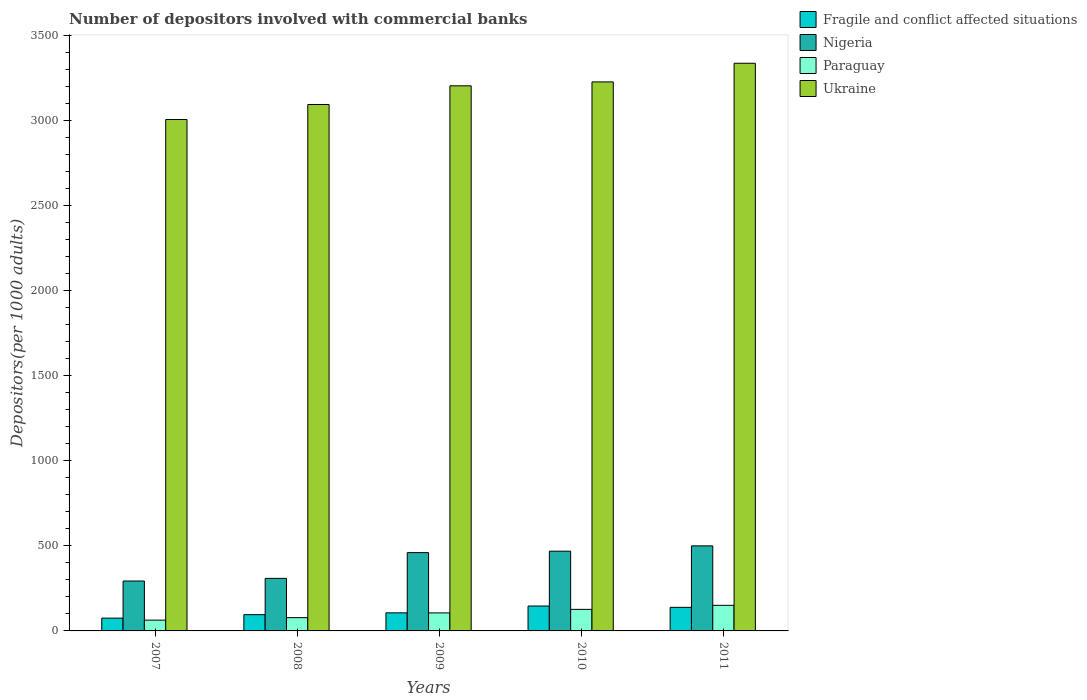Are the number of bars per tick equal to the number of legend labels?
Provide a short and direct response. Yes. Are the number of bars on each tick of the X-axis equal?
Your answer should be very brief. Yes. How many bars are there on the 2nd tick from the right?
Ensure brevity in your answer.  4. In how many cases, is the number of bars for a given year not equal to the number of legend labels?
Make the answer very short. 0. What is the number of depositors involved with commercial banks in Fragile and conflict affected situations in 2010?
Your answer should be very brief. 146.5. Across all years, what is the maximum number of depositors involved with commercial banks in Nigeria?
Your answer should be very brief. 500.36. Across all years, what is the minimum number of depositors involved with commercial banks in Fragile and conflict affected situations?
Provide a short and direct response. 75.3. In which year was the number of depositors involved with commercial banks in Paraguay minimum?
Your answer should be compact. 2007. What is the total number of depositors involved with commercial banks in Paraguay in the graph?
Your answer should be compact. 524.67. What is the difference between the number of depositors involved with commercial banks in Fragile and conflict affected situations in 2007 and that in 2008?
Keep it short and to the point. -20.35. What is the difference between the number of depositors involved with commercial banks in Nigeria in 2008 and the number of depositors involved with commercial banks in Fragile and conflict affected situations in 2011?
Your answer should be very brief. 170.43. What is the average number of depositors involved with commercial banks in Ukraine per year?
Offer a terse response. 3176.16. In the year 2010, what is the difference between the number of depositors involved with commercial banks in Ukraine and number of depositors involved with commercial banks in Paraguay?
Offer a terse response. 3102.9. In how many years, is the number of depositors involved with commercial banks in Fragile and conflict affected situations greater than 1100?
Offer a terse response. 0. What is the ratio of the number of depositors involved with commercial banks in Paraguay in 2007 to that in 2009?
Make the answer very short. 0.6. What is the difference between the highest and the second highest number of depositors involved with commercial banks in Nigeria?
Your answer should be compact. 31.38. What is the difference between the highest and the lowest number of depositors involved with commercial banks in Nigeria?
Ensure brevity in your answer.  206.77. Is the sum of the number of depositors involved with commercial banks in Fragile and conflict affected situations in 2007 and 2009 greater than the maximum number of depositors involved with commercial banks in Paraguay across all years?
Your response must be concise. Yes. Is it the case that in every year, the sum of the number of depositors involved with commercial banks in Fragile and conflict affected situations and number of depositors involved with commercial banks in Paraguay is greater than the sum of number of depositors involved with commercial banks in Ukraine and number of depositors involved with commercial banks in Nigeria?
Offer a very short reply. No. What does the 4th bar from the left in 2009 represents?
Offer a terse response. Ukraine. What does the 4th bar from the right in 2011 represents?
Make the answer very short. Fragile and conflict affected situations. Is it the case that in every year, the sum of the number of depositors involved with commercial banks in Nigeria and number of depositors involved with commercial banks in Paraguay is greater than the number of depositors involved with commercial banks in Fragile and conflict affected situations?
Your answer should be very brief. Yes. How many years are there in the graph?
Your response must be concise. 5. What is the difference between two consecutive major ticks on the Y-axis?
Keep it short and to the point. 500. Does the graph contain any zero values?
Your response must be concise. No. Does the graph contain grids?
Offer a very short reply. No. Where does the legend appear in the graph?
Your response must be concise. Top right. How are the legend labels stacked?
Give a very brief answer. Vertical. What is the title of the graph?
Offer a terse response. Number of depositors involved with commercial banks. Does "Congo (Republic)" appear as one of the legend labels in the graph?
Your answer should be very brief. No. What is the label or title of the X-axis?
Ensure brevity in your answer.  Years. What is the label or title of the Y-axis?
Your answer should be compact. Depositors(per 1000 adults). What is the Depositors(per 1000 adults) in Fragile and conflict affected situations in 2007?
Your answer should be compact. 75.3. What is the Depositors(per 1000 adults) in Nigeria in 2007?
Make the answer very short. 293.59. What is the Depositors(per 1000 adults) in Paraguay in 2007?
Offer a very short reply. 63.43. What is the Depositors(per 1000 adults) of Ukraine in 2007?
Give a very brief answer. 3008.39. What is the Depositors(per 1000 adults) of Fragile and conflict affected situations in 2008?
Give a very brief answer. 95.65. What is the Depositors(per 1000 adults) of Nigeria in 2008?
Provide a succinct answer. 309.17. What is the Depositors(per 1000 adults) in Paraguay in 2008?
Your response must be concise. 78.05. What is the Depositors(per 1000 adults) in Ukraine in 2008?
Your answer should be compact. 3096.67. What is the Depositors(per 1000 adults) of Fragile and conflict affected situations in 2009?
Your response must be concise. 106.41. What is the Depositors(per 1000 adults) of Nigeria in 2009?
Keep it short and to the point. 460.66. What is the Depositors(per 1000 adults) in Paraguay in 2009?
Give a very brief answer. 105.92. What is the Depositors(per 1000 adults) of Ukraine in 2009?
Provide a succinct answer. 3206.64. What is the Depositors(per 1000 adults) in Fragile and conflict affected situations in 2010?
Make the answer very short. 146.5. What is the Depositors(per 1000 adults) of Nigeria in 2010?
Ensure brevity in your answer.  468.98. What is the Depositors(per 1000 adults) of Paraguay in 2010?
Your answer should be very brief. 126.8. What is the Depositors(per 1000 adults) of Ukraine in 2010?
Your response must be concise. 3229.69. What is the Depositors(per 1000 adults) in Fragile and conflict affected situations in 2011?
Make the answer very short. 138.74. What is the Depositors(per 1000 adults) of Nigeria in 2011?
Ensure brevity in your answer.  500.36. What is the Depositors(per 1000 adults) of Paraguay in 2011?
Offer a terse response. 150.47. What is the Depositors(per 1000 adults) in Ukraine in 2011?
Give a very brief answer. 3339.41. Across all years, what is the maximum Depositors(per 1000 adults) of Fragile and conflict affected situations?
Make the answer very short. 146.5. Across all years, what is the maximum Depositors(per 1000 adults) in Nigeria?
Your answer should be compact. 500.36. Across all years, what is the maximum Depositors(per 1000 adults) of Paraguay?
Your response must be concise. 150.47. Across all years, what is the maximum Depositors(per 1000 adults) in Ukraine?
Provide a succinct answer. 3339.41. Across all years, what is the minimum Depositors(per 1000 adults) in Fragile and conflict affected situations?
Provide a short and direct response. 75.3. Across all years, what is the minimum Depositors(per 1000 adults) in Nigeria?
Provide a succinct answer. 293.59. Across all years, what is the minimum Depositors(per 1000 adults) in Paraguay?
Your response must be concise. 63.43. Across all years, what is the minimum Depositors(per 1000 adults) in Ukraine?
Offer a very short reply. 3008.39. What is the total Depositors(per 1000 adults) of Fragile and conflict affected situations in the graph?
Your answer should be compact. 562.6. What is the total Depositors(per 1000 adults) in Nigeria in the graph?
Provide a succinct answer. 2032.76. What is the total Depositors(per 1000 adults) of Paraguay in the graph?
Provide a succinct answer. 524.67. What is the total Depositors(per 1000 adults) in Ukraine in the graph?
Provide a short and direct response. 1.59e+04. What is the difference between the Depositors(per 1000 adults) of Fragile and conflict affected situations in 2007 and that in 2008?
Ensure brevity in your answer.  -20.35. What is the difference between the Depositors(per 1000 adults) of Nigeria in 2007 and that in 2008?
Provide a succinct answer. -15.58. What is the difference between the Depositors(per 1000 adults) in Paraguay in 2007 and that in 2008?
Your response must be concise. -14.62. What is the difference between the Depositors(per 1000 adults) of Ukraine in 2007 and that in 2008?
Your answer should be very brief. -88.28. What is the difference between the Depositors(per 1000 adults) of Fragile and conflict affected situations in 2007 and that in 2009?
Give a very brief answer. -31.11. What is the difference between the Depositors(per 1000 adults) of Nigeria in 2007 and that in 2009?
Provide a succinct answer. -167.06. What is the difference between the Depositors(per 1000 adults) in Paraguay in 2007 and that in 2009?
Provide a succinct answer. -42.48. What is the difference between the Depositors(per 1000 adults) of Ukraine in 2007 and that in 2009?
Provide a short and direct response. -198.25. What is the difference between the Depositors(per 1000 adults) of Fragile and conflict affected situations in 2007 and that in 2010?
Your answer should be compact. -71.2. What is the difference between the Depositors(per 1000 adults) in Nigeria in 2007 and that in 2010?
Make the answer very short. -175.39. What is the difference between the Depositors(per 1000 adults) of Paraguay in 2007 and that in 2010?
Your answer should be very brief. -63.36. What is the difference between the Depositors(per 1000 adults) in Ukraine in 2007 and that in 2010?
Offer a terse response. -221.3. What is the difference between the Depositors(per 1000 adults) of Fragile and conflict affected situations in 2007 and that in 2011?
Your response must be concise. -63.44. What is the difference between the Depositors(per 1000 adults) of Nigeria in 2007 and that in 2011?
Offer a very short reply. -206.77. What is the difference between the Depositors(per 1000 adults) in Paraguay in 2007 and that in 2011?
Give a very brief answer. -87.03. What is the difference between the Depositors(per 1000 adults) in Ukraine in 2007 and that in 2011?
Provide a short and direct response. -331.02. What is the difference between the Depositors(per 1000 adults) in Fragile and conflict affected situations in 2008 and that in 2009?
Offer a terse response. -10.75. What is the difference between the Depositors(per 1000 adults) of Nigeria in 2008 and that in 2009?
Your response must be concise. -151.48. What is the difference between the Depositors(per 1000 adults) in Paraguay in 2008 and that in 2009?
Offer a terse response. -27.87. What is the difference between the Depositors(per 1000 adults) in Ukraine in 2008 and that in 2009?
Provide a short and direct response. -109.97. What is the difference between the Depositors(per 1000 adults) of Fragile and conflict affected situations in 2008 and that in 2010?
Make the answer very short. -50.84. What is the difference between the Depositors(per 1000 adults) of Nigeria in 2008 and that in 2010?
Give a very brief answer. -159.8. What is the difference between the Depositors(per 1000 adults) of Paraguay in 2008 and that in 2010?
Give a very brief answer. -48.75. What is the difference between the Depositors(per 1000 adults) in Ukraine in 2008 and that in 2010?
Provide a short and direct response. -133.02. What is the difference between the Depositors(per 1000 adults) in Fragile and conflict affected situations in 2008 and that in 2011?
Offer a terse response. -43.09. What is the difference between the Depositors(per 1000 adults) in Nigeria in 2008 and that in 2011?
Provide a short and direct response. -191.18. What is the difference between the Depositors(per 1000 adults) in Paraguay in 2008 and that in 2011?
Provide a succinct answer. -72.42. What is the difference between the Depositors(per 1000 adults) of Ukraine in 2008 and that in 2011?
Your response must be concise. -242.74. What is the difference between the Depositors(per 1000 adults) of Fragile and conflict affected situations in 2009 and that in 2010?
Your answer should be very brief. -40.09. What is the difference between the Depositors(per 1000 adults) of Nigeria in 2009 and that in 2010?
Your response must be concise. -8.32. What is the difference between the Depositors(per 1000 adults) in Paraguay in 2009 and that in 2010?
Your answer should be compact. -20.88. What is the difference between the Depositors(per 1000 adults) of Ukraine in 2009 and that in 2010?
Your answer should be very brief. -23.06. What is the difference between the Depositors(per 1000 adults) of Fragile and conflict affected situations in 2009 and that in 2011?
Your response must be concise. -32.34. What is the difference between the Depositors(per 1000 adults) in Nigeria in 2009 and that in 2011?
Make the answer very short. -39.7. What is the difference between the Depositors(per 1000 adults) of Paraguay in 2009 and that in 2011?
Make the answer very short. -44.55. What is the difference between the Depositors(per 1000 adults) in Ukraine in 2009 and that in 2011?
Your answer should be compact. -132.77. What is the difference between the Depositors(per 1000 adults) in Fragile and conflict affected situations in 2010 and that in 2011?
Keep it short and to the point. 7.75. What is the difference between the Depositors(per 1000 adults) of Nigeria in 2010 and that in 2011?
Provide a short and direct response. -31.38. What is the difference between the Depositors(per 1000 adults) of Paraguay in 2010 and that in 2011?
Your answer should be very brief. -23.67. What is the difference between the Depositors(per 1000 adults) of Ukraine in 2010 and that in 2011?
Ensure brevity in your answer.  -109.71. What is the difference between the Depositors(per 1000 adults) of Fragile and conflict affected situations in 2007 and the Depositors(per 1000 adults) of Nigeria in 2008?
Offer a very short reply. -233.88. What is the difference between the Depositors(per 1000 adults) of Fragile and conflict affected situations in 2007 and the Depositors(per 1000 adults) of Paraguay in 2008?
Your answer should be very brief. -2.75. What is the difference between the Depositors(per 1000 adults) of Fragile and conflict affected situations in 2007 and the Depositors(per 1000 adults) of Ukraine in 2008?
Provide a short and direct response. -3021.37. What is the difference between the Depositors(per 1000 adults) of Nigeria in 2007 and the Depositors(per 1000 adults) of Paraguay in 2008?
Give a very brief answer. 215.54. What is the difference between the Depositors(per 1000 adults) in Nigeria in 2007 and the Depositors(per 1000 adults) in Ukraine in 2008?
Ensure brevity in your answer.  -2803.08. What is the difference between the Depositors(per 1000 adults) in Paraguay in 2007 and the Depositors(per 1000 adults) in Ukraine in 2008?
Provide a succinct answer. -3033.23. What is the difference between the Depositors(per 1000 adults) in Fragile and conflict affected situations in 2007 and the Depositors(per 1000 adults) in Nigeria in 2009?
Your answer should be compact. -385.36. What is the difference between the Depositors(per 1000 adults) in Fragile and conflict affected situations in 2007 and the Depositors(per 1000 adults) in Paraguay in 2009?
Provide a short and direct response. -30.62. What is the difference between the Depositors(per 1000 adults) in Fragile and conflict affected situations in 2007 and the Depositors(per 1000 adults) in Ukraine in 2009?
Make the answer very short. -3131.34. What is the difference between the Depositors(per 1000 adults) in Nigeria in 2007 and the Depositors(per 1000 adults) in Paraguay in 2009?
Your response must be concise. 187.67. What is the difference between the Depositors(per 1000 adults) of Nigeria in 2007 and the Depositors(per 1000 adults) of Ukraine in 2009?
Keep it short and to the point. -2913.05. What is the difference between the Depositors(per 1000 adults) of Paraguay in 2007 and the Depositors(per 1000 adults) of Ukraine in 2009?
Make the answer very short. -3143.2. What is the difference between the Depositors(per 1000 adults) in Fragile and conflict affected situations in 2007 and the Depositors(per 1000 adults) in Nigeria in 2010?
Your response must be concise. -393.68. What is the difference between the Depositors(per 1000 adults) of Fragile and conflict affected situations in 2007 and the Depositors(per 1000 adults) of Paraguay in 2010?
Keep it short and to the point. -51.5. What is the difference between the Depositors(per 1000 adults) in Fragile and conflict affected situations in 2007 and the Depositors(per 1000 adults) in Ukraine in 2010?
Your answer should be compact. -3154.39. What is the difference between the Depositors(per 1000 adults) of Nigeria in 2007 and the Depositors(per 1000 adults) of Paraguay in 2010?
Provide a short and direct response. 166.79. What is the difference between the Depositors(per 1000 adults) of Nigeria in 2007 and the Depositors(per 1000 adults) of Ukraine in 2010?
Your response must be concise. -2936.1. What is the difference between the Depositors(per 1000 adults) of Paraguay in 2007 and the Depositors(per 1000 adults) of Ukraine in 2010?
Offer a terse response. -3166.26. What is the difference between the Depositors(per 1000 adults) of Fragile and conflict affected situations in 2007 and the Depositors(per 1000 adults) of Nigeria in 2011?
Give a very brief answer. -425.06. What is the difference between the Depositors(per 1000 adults) in Fragile and conflict affected situations in 2007 and the Depositors(per 1000 adults) in Paraguay in 2011?
Your answer should be very brief. -75.17. What is the difference between the Depositors(per 1000 adults) of Fragile and conflict affected situations in 2007 and the Depositors(per 1000 adults) of Ukraine in 2011?
Give a very brief answer. -3264.11. What is the difference between the Depositors(per 1000 adults) in Nigeria in 2007 and the Depositors(per 1000 adults) in Paraguay in 2011?
Provide a succinct answer. 143.12. What is the difference between the Depositors(per 1000 adults) in Nigeria in 2007 and the Depositors(per 1000 adults) in Ukraine in 2011?
Your answer should be very brief. -3045.81. What is the difference between the Depositors(per 1000 adults) in Paraguay in 2007 and the Depositors(per 1000 adults) in Ukraine in 2011?
Provide a short and direct response. -3275.97. What is the difference between the Depositors(per 1000 adults) of Fragile and conflict affected situations in 2008 and the Depositors(per 1000 adults) of Nigeria in 2009?
Your answer should be compact. -365. What is the difference between the Depositors(per 1000 adults) in Fragile and conflict affected situations in 2008 and the Depositors(per 1000 adults) in Paraguay in 2009?
Offer a very short reply. -10.27. What is the difference between the Depositors(per 1000 adults) in Fragile and conflict affected situations in 2008 and the Depositors(per 1000 adults) in Ukraine in 2009?
Make the answer very short. -3110.99. What is the difference between the Depositors(per 1000 adults) of Nigeria in 2008 and the Depositors(per 1000 adults) of Paraguay in 2009?
Your answer should be compact. 203.26. What is the difference between the Depositors(per 1000 adults) in Nigeria in 2008 and the Depositors(per 1000 adults) in Ukraine in 2009?
Make the answer very short. -2897.46. What is the difference between the Depositors(per 1000 adults) in Paraguay in 2008 and the Depositors(per 1000 adults) in Ukraine in 2009?
Your answer should be very brief. -3128.59. What is the difference between the Depositors(per 1000 adults) in Fragile and conflict affected situations in 2008 and the Depositors(per 1000 adults) in Nigeria in 2010?
Keep it short and to the point. -373.33. What is the difference between the Depositors(per 1000 adults) in Fragile and conflict affected situations in 2008 and the Depositors(per 1000 adults) in Paraguay in 2010?
Offer a very short reply. -31.15. What is the difference between the Depositors(per 1000 adults) of Fragile and conflict affected situations in 2008 and the Depositors(per 1000 adults) of Ukraine in 2010?
Your response must be concise. -3134.04. What is the difference between the Depositors(per 1000 adults) of Nigeria in 2008 and the Depositors(per 1000 adults) of Paraguay in 2010?
Make the answer very short. 182.38. What is the difference between the Depositors(per 1000 adults) of Nigeria in 2008 and the Depositors(per 1000 adults) of Ukraine in 2010?
Provide a succinct answer. -2920.52. What is the difference between the Depositors(per 1000 adults) in Paraguay in 2008 and the Depositors(per 1000 adults) in Ukraine in 2010?
Provide a short and direct response. -3151.64. What is the difference between the Depositors(per 1000 adults) of Fragile and conflict affected situations in 2008 and the Depositors(per 1000 adults) of Nigeria in 2011?
Ensure brevity in your answer.  -404.7. What is the difference between the Depositors(per 1000 adults) in Fragile and conflict affected situations in 2008 and the Depositors(per 1000 adults) in Paraguay in 2011?
Give a very brief answer. -54.82. What is the difference between the Depositors(per 1000 adults) of Fragile and conflict affected situations in 2008 and the Depositors(per 1000 adults) of Ukraine in 2011?
Provide a succinct answer. -3243.75. What is the difference between the Depositors(per 1000 adults) in Nigeria in 2008 and the Depositors(per 1000 adults) in Paraguay in 2011?
Your response must be concise. 158.71. What is the difference between the Depositors(per 1000 adults) in Nigeria in 2008 and the Depositors(per 1000 adults) in Ukraine in 2011?
Provide a succinct answer. -3030.23. What is the difference between the Depositors(per 1000 adults) in Paraguay in 2008 and the Depositors(per 1000 adults) in Ukraine in 2011?
Your answer should be very brief. -3261.36. What is the difference between the Depositors(per 1000 adults) of Fragile and conflict affected situations in 2009 and the Depositors(per 1000 adults) of Nigeria in 2010?
Make the answer very short. -362.57. What is the difference between the Depositors(per 1000 adults) in Fragile and conflict affected situations in 2009 and the Depositors(per 1000 adults) in Paraguay in 2010?
Ensure brevity in your answer.  -20.39. What is the difference between the Depositors(per 1000 adults) of Fragile and conflict affected situations in 2009 and the Depositors(per 1000 adults) of Ukraine in 2010?
Offer a very short reply. -3123.29. What is the difference between the Depositors(per 1000 adults) in Nigeria in 2009 and the Depositors(per 1000 adults) in Paraguay in 2010?
Offer a terse response. 333.86. What is the difference between the Depositors(per 1000 adults) of Nigeria in 2009 and the Depositors(per 1000 adults) of Ukraine in 2010?
Provide a short and direct response. -2769.04. What is the difference between the Depositors(per 1000 adults) in Paraguay in 2009 and the Depositors(per 1000 adults) in Ukraine in 2010?
Keep it short and to the point. -3123.78. What is the difference between the Depositors(per 1000 adults) of Fragile and conflict affected situations in 2009 and the Depositors(per 1000 adults) of Nigeria in 2011?
Your response must be concise. -393.95. What is the difference between the Depositors(per 1000 adults) of Fragile and conflict affected situations in 2009 and the Depositors(per 1000 adults) of Paraguay in 2011?
Your response must be concise. -44.06. What is the difference between the Depositors(per 1000 adults) in Fragile and conflict affected situations in 2009 and the Depositors(per 1000 adults) in Ukraine in 2011?
Offer a terse response. -3233. What is the difference between the Depositors(per 1000 adults) in Nigeria in 2009 and the Depositors(per 1000 adults) in Paraguay in 2011?
Provide a succinct answer. 310.19. What is the difference between the Depositors(per 1000 adults) of Nigeria in 2009 and the Depositors(per 1000 adults) of Ukraine in 2011?
Make the answer very short. -2878.75. What is the difference between the Depositors(per 1000 adults) of Paraguay in 2009 and the Depositors(per 1000 adults) of Ukraine in 2011?
Provide a short and direct response. -3233.49. What is the difference between the Depositors(per 1000 adults) in Fragile and conflict affected situations in 2010 and the Depositors(per 1000 adults) in Nigeria in 2011?
Offer a very short reply. -353.86. What is the difference between the Depositors(per 1000 adults) of Fragile and conflict affected situations in 2010 and the Depositors(per 1000 adults) of Paraguay in 2011?
Offer a very short reply. -3.97. What is the difference between the Depositors(per 1000 adults) of Fragile and conflict affected situations in 2010 and the Depositors(per 1000 adults) of Ukraine in 2011?
Your response must be concise. -3192.91. What is the difference between the Depositors(per 1000 adults) in Nigeria in 2010 and the Depositors(per 1000 adults) in Paraguay in 2011?
Your response must be concise. 318.51. What is the difference between the Depositors(per 1000 adults) in Nigeria in 2010 and the Depositors(per 1000 adults) in Ukraine in 2011?
Your answer should be very brief. -2870.43. What is the difference between the Depositors(per 1000 adults) of Paraguay in 2010 and the Depositors(per 1000 adults) of Ukraine in 2011?
Your answer should be very brief. -3212.61. What is the average Depositors(per 1000 adults) in Fragile and conflict affected situations per year?
Keep it short and to the point. 112.52. What is the average Depositors(per 1000 adults) in Nigeria per year?
Your response must be concise. 406.55. What is the average Depositors(per 1000 adults) in Paraguay per year?
Make the answer very short. 104.93. What is the average Depositors(per 1000 adults) in Ukraine per year?
Keep it short and to the point. 3176.16. In the year 2007, what is the difference between the Depositors(per 1000 adults) in Fragile and conflict affected situations and Depositors(per 1000 adults) in Nigeria?
Keep it short and to the point. -218.29. In the year 2007, what is the difference between the Depositors(per 1000 adults) in Fragile and conflict affected situations and Depositors(per 1000 adults) in Paraguay?
Your answer should be compact. 11.86. In the year 2007, what is the difference between the Depositors(per 1000 adults) in Fragile and conflict affected situations and Depositors(per 1000 adults) in Ukraine?
Ensure brevity in your answer.  -2933.09. In the year 2007, what is the difference between the Depositors(per 1000 adults) in Nigeria and Depositors(per 1000 adults) in Paraguay?
Your answer should be very brief. 230.16. In the year 2007, what is the difference between the Depositors(per 1000 adults) of Nigeria and Depositors(per 1000 adults) of Ukraine?
Your response must be concise. -2714.8. In the year 2007, what is the difference between the Depositors(per 1000 adults) of Paraguay and Depositors(per 1000 adults) of Ukraine?
Your answer should be very brief. -2944.95. In the year 2008, what is the difference between the Depositors(per 1000 adults) in Fragile and conflict affected situations and Depositors(per 1000 adults) in Nigeria?
Provide a short and direct response. -213.52. In the year 2008, what is the difference between the Depositors(per 1000 adults) in Fragile and conflict affected situations and Depositors(per 1000 adults) in Paraguay?
Make the answer very short. 17.6. In the year 2008, what is the difference between the Depositors(per 1000 adults) in Fragile and conflict affected situations and Depositors(per 1000 adults) in Ukraine?
Keep it short and to the point. -3001.02. In the year 2008, what is the difference between the Depositors(per 1000 adults) in Nigeria and Depositors(per 1000 adults) in Paraguay?
Provide a succinct answer. 231.12. In the year 2008, what is the difference between the Depositors(per 1000 adults) of Nigeria and Depositors(per 1000 adults) of Ukraine?
Make the answer very short. -2787.49. In the year 2008, what is the difference between the Depositors(per 1000 adults) in Paraguay and Depositors(per 1000 adults) in Ukraine?
Provide a short and direct response. -3018.62. In the year 2009, what is the difference between the Depositors(per 1000 adults) in Fragile and conflict affected situations and Depositors(per 1000 adults) in Nigeria?
Offer a terse response. -354.25. In the year 2009, what is the difference between the Depositors(per 1000 adults) in Fragile and conflict affected situations and Depositors(per 1000 adults) in Paraguay?
Your response must be concise. 0.49. In the year 2009, what is the difference between the Depositors(per 1000 adults) in Fragile and conflict affected situations and Depositors(per 1000 adults) in Ukraine?
Offer a very short reply. -3100.23. In the year 2009, what is the difference between the Depositors(per 1000 adults) in Nigeria and Depositors(per 1000 adults) in Paraguay?
Your answer should be compact. 354.74. In the year 2009, what is the difference between the Depositors(per 1000 adults) in Nigeria and Depositors(per 1000 adults) in Ukraine?
Offer a terse response. -2745.98. In the year 2009, what is the difference between the Depositors(per 1000 adults) of Paraguay and Depositors(per 1000 adults) of Ukraine?
Offer a terse response. -3100.72. In the year 2010, what is the difference between the Depositors(per 1000 adults) of Fragile and conflict affected situations and Depositors(per 1000 adults) of Nigeria?
Your response must be concise. -322.48. In the year 2010, what is the difference between the Depositors(per 1000 adults) of Fragile and conflict affected situations and Depositors(per 1000 adults) of Paraguay?
Offer a terse response. 19.7. In the year 2010, what is the difference between the Depositors(per 1000 adults) of Fragile and conflict affected situations and Depositors(per 1000 adults) of Ukraine?
Give a very brief answer. -3083.2. In the year 2010, what is the difference between the Depositors(per 1000 adults) of Nigeria and Depositors(per 1000 adults) of Paraguay?
Your answer should be very brief. 342.18. In the year 2010, what is the difference between the Depositors(per 1000 adults) in Nigeria and Depositors(per 1000 adults) in Ukraine?
Offer a terse response. -2760.71. In the year 2010, what is the difference between the Depositors(per 1000 adults) of Paraguay and Depositors(per 1000 adults) of Ukraine?
Your response must be concise. -3102.9. In the year 2011, what is the difference between the Depositors(per 1000 adults) of Fragile and conflict affected situations and Depositors(per 1000 adults) of Nigeria?
Provide a short and direct response. -361.61. In the year 2011, what is the difference between the Depositors(per 1000 adults) in Fragile and conflict affected situations and Depositors(per 1000 adults) in Paraguay?
Your answer should be very brief. -11.72. In the year 2011, what is the difference between the Depositors(per 1000 adults) of Fragile and conflict affected situations and Depositors(per 1000 adults) of Ukraine?
Give a very brief answer. -3200.66. In the year 2011, what is the difference between the Depositors(per 1000 adults) in Nigeria and Depositors(per 1000 adults) in Paraguay?
Your response must be concise. 349.89. In the year 2011, what is the difference between the Depositors(per 1000 adults) in Nigeria and Depositors(per 1000 adults) in Ukraine?
Offer a terse response. -2839.05. In the year 2011, what is the difference between the Depositors(per 1000 adults) of Paraguay and Depositors(per 1000 adults) of Ukraine?
Make the answer very short. -3188.94. What is the ratio of the Depositors(per 1000 adults) of Fragile and conflict affected situations in 2007 to that in 2008?
Provide a succinct answer. 0.79. What is the ratio of the Depositors(per 1000 adults) in Nigeria in 2007 to that in 2008?
Your answer should be compact. 0.95. What is the ratio of the Depositors(per 1000 adults) in Paraguay in 2007 to that in 2008?
Your answer should be compact. 0.81. What is the ratio of the Depositors(per 1000 adults) in Ukraine in 2007 to that in 2008?
Your answer should be very brief. 0.97. What is the ratio of the Depositors(per 1000 adults) of Fragile and conflict affected situations in 2007 to that in 2009?
Offer a very short reply. 0.71. What is the ratio of the Depositors(per 1000 adults) of Nigeria in 2007 to that in 2009?
Your response must be concise. 0.64. What is the ratio of the Depositors(per 1000 adults) of Paraguay in 2007 to that in 2009?
Provide a short and direct response. 0.6. What is the ratio of the Depositors(per 1000 adults) of Ukraine in 2007 to that in 2009?
Your answer should be compact. 0.94. What is the ratio of the Depositors(per 1000 adults) in Fragile and conflict affected situations in 2007 to that in 2010?
Your answer should be compact. 0.51. What is the ratio of the Depositors(per 1000 adults) of Nigeria in 2007 to that in 2010?
Your answer should be compact. 0.63. What is the ratio of the Depositors(per 1000 adults) in Paraguay in 2007 to that in 2010?
Your response must be concise. 0.5. What is the ratio of the Depositors(per 1000 adults) in Ukraine in 2007 to that in 2010?
Give a very brief answer. 0.93. What is the ratio of the Depositors(per 1000 adults) in Fragile and conflict affected situations in 2007 to that in 2011?
Offer a very short reply. 0.54. What is the ratio of the Depositors(per 1000 adults) in Nigeria in 2007 to that in 2011?
Your answer should be compact. 0.59. What is the ratio of the Depositors(per 1000 adults) in Paraguay in 2007 to that in 2011?
Your response must be concise. 0.42. What is the ratio of the Depositors(per 1000 adults) in Ukraine in 2007 to that in 2011?
Your answer should be very brief. 0.9. What is the ratio of the Depositors(per 1000 adults) in Fragile and conflict affected situations in 2008 to that in 2009?
Your answer should be compact. 0.9. What is the ratio of the Depositors(per 1000 adults) of Nigeria in 2008 to that in 2009?
Keep it short and to the point. 0.67. What is the ratio of the Depositors(per 1000 adults) in Paraguay in 2008 to that in 2009?
Keep it short and to the point. 0.74. What is the ratio of the Depositors(per 1000 adults) in Ukraine in 2008 to that in 2009?
Keep it short and to the point. 0.97. What is the ratio of the Depositors(per 1000 adults) in Fragile and conflict affected situations in 2008 to that in 2010?
Offer a terse response. 0.65. What is the ratio of the Depositors(per 1000 adults) in Nigeria in 2008 to that in 2010?
Give a very brief answer. 0.66. What is the ratio of the Depositors(per 1000 adults) in Paraguay in 2008 to that in 2010?
Keep it short and to the point. 0.62. What is the ratio of the Depositors(per 1000 adults) in Ukraine in 2008 to that in 2010?
Provide a succinct answer. 0.96. What is the ratio of the Depositors(per 1000 adults) of Fragile and conflict affected situations in 2008 to that in 2011?
Your answer should be compact. 0.69. What is the ratio of the Depositors(per 1000 adults) in Nigeria in 2008 to that in 2011?
Make the answer very short. 0.62. What is the ratio of the Depositors(per 1000 adults) of Paraguay in 2008 to that in 2011?
Give a very brief answer. 0.52. What is the ratio of the Depositors(per 1000 adults) of Ukraine in 2008 to that in 2011?
Offer a terse response. 0.93. What is the ratio of the Depositors(per 1000 adults) in Fragile and conflict affected situations in 2009 to that in 2010?
Your response must be concise. 0.73. What is the ratio of the Depositors(per 1000 adults) in Nigeria in 2009 to that in 2010?
Make the answer very short. 0.98. What is the ratio of the Depositors(per 1000 adults) in Paraguay in 2009 to that in 2010?
Provide a succinct answer. 0.84. What is the ratio of the Depositors(per 1000 adults) in Fragile and conflict affected situations in 2009 to that in 2011?
Your answer should be very brief. 0.77. What is the ratio of the Depositors(per 1000 adults) of Nigeria in 2009 to that in 2011?
Provide a short and direct response. 0.92. What is the ratio of the Depositors(per 1000 adults) in Paraguay in 2009 to that in 2011?
Offer a very short reply. 0.7. What is the ratio of the Depositors(per 1000 adults) of Ukraine in 2009 to that in 2011?
Give a very brief answer. 0.96. What is the ratio of the Depositors(per 1000 adults) of Fragile and conflict affected situations in 2010 to that in 2011?
Offer a very short reply. 1.06. What is the ratio of the Depositors(per 1000 adults) in Nigeria in 2010 to that in 2011?
Provide a succinct answer. 0.94. What is the ratio of the Depositors(per 1000 adults) of Paraguay in 2010 to that in 2011?
Ensure brevity in your answer.  0.84. What is the ratio of the Depositors(per 1000 adults) of Ukraine in 2010 to that in 2011?
Your answer should be compact. 0.97. What is the difference between the highest and the second highest Depositors(per 1000 adults) in Fragile and conflict affected situations?
Keep it short and to the point. 7.75. What is the difference between the highest and the second highest Depositors(per 1000 adults) in Nigeria?
Provide a short and direct response. 31.38. What is the difference between the highest and the second highest Depositors(per 1000 adults) of Paraguay?
Offer a very short reply. 23.67. What is the difference between the highest and the second highest Depositors(per 1000 adults) of Ukraine?
Offer a terse response. 109.71. What is the difference between the highest and the lowest Depositors(per 1000 adults) in Fragile and conflict affected situations?
Make the answer very short. 71.2. What is the difference between the highest and the lowest Depositors(per 1000 adults) of Nigeria?
Your response must be concise. 206.77. What is the difference between the highest and the lowest Depositors(per 1000 adults) of Paraguay?
Ensure brevity in your answer.  87.03. What is the difference between the highest and the lowest Depositors(per 1000 adults) of Ukraine?
Provide a succinct answer. 331.02. 